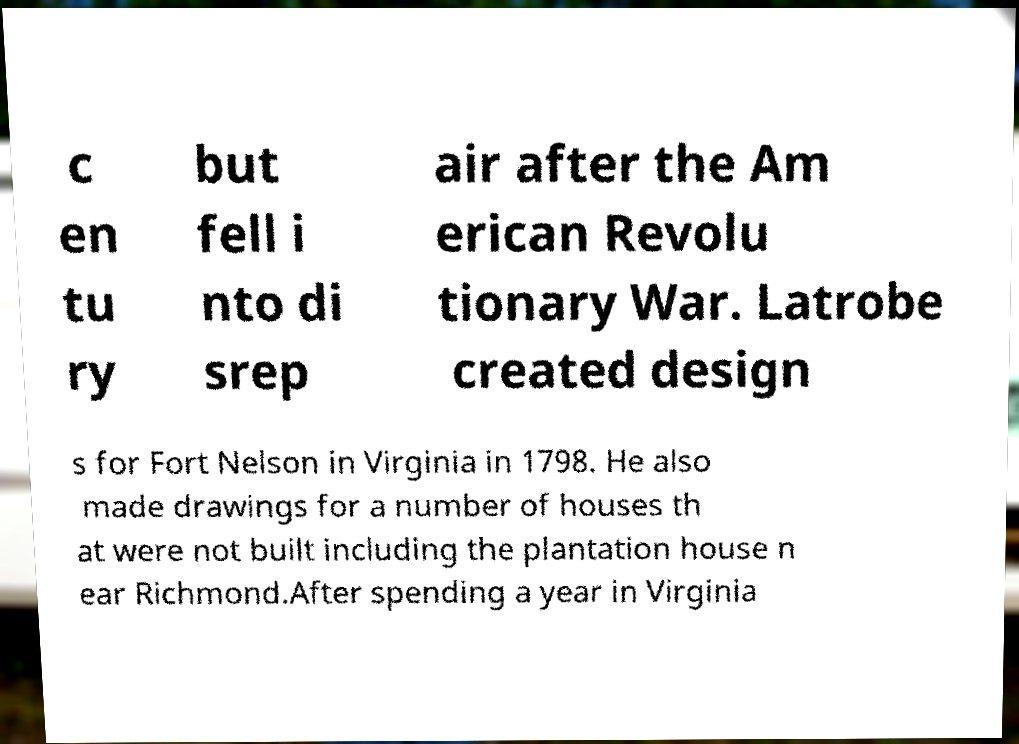For documentation purposes, I need the text within this image transcribed. Could you provide that? c en tu ry but fell i nto di srep air after the Am erican Revolu tionary War. Latrobe created design s for Fort Nelson in Virginia in 1798. He also made drawings for a number of houses th at were not built including the plantation house n ear Richmond.After spending a year in Virginia 